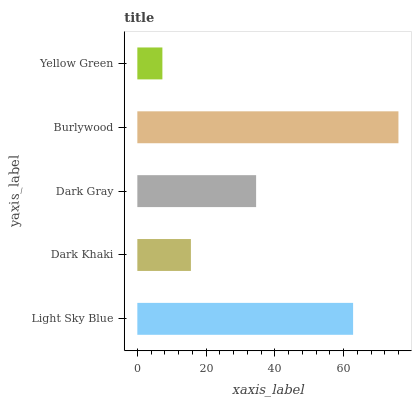Is Yellow Green the minimum?
Answer yes or no. Yes. Is Burlywood the maximum?
Answer yes or no. Yes. Is Dark Khaki the minimum?
Answer yes or no. No. Is Dark Khaki the maximum?
Answer yes or no. No. Is Light Sky Blue greater than Dark Khaki?
Answer yes or no. Yes. Is Dark Khaki less than Light Sky Blue?
Answer yes or no. Yes. Is Dark Khaki greater than Light Sky Blue?
Answer yes or no. No. Is Light Sky Blue less than Dark Khaki?
Answer yes or no. No. Is Dark Gray the high median?
Answer yes or no. Yes. Is Dark Gray the low median?
Answer yes or no. Yes. Is Yellow Green the high median?
Answer yes or no. No. Is Dark Khaki the low median?
Answer yes or no. No. 